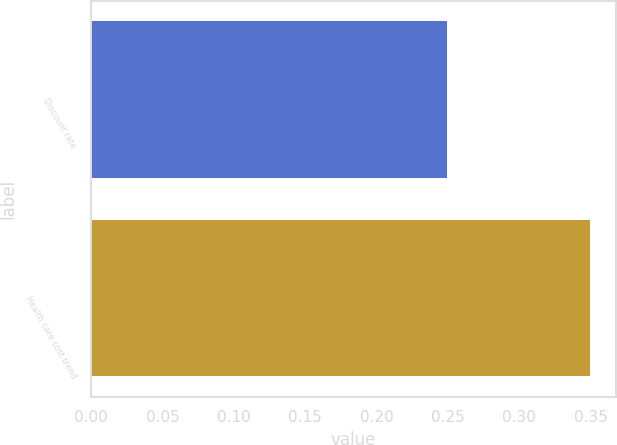Convert chart. <chart><loc_0><loc_0><loc_500><loc_500><bar_chart><fcel>Discount rate<fcel>Health care cost trend<nl><fcel>0.25<fcel>0.35<nl></chart> 